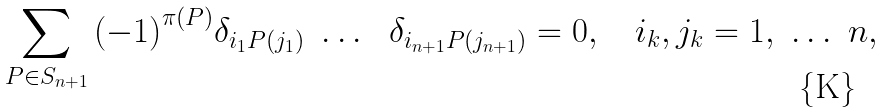Convert formula to latex. <formula><loc_0><loc_0><loc_500><loc_500>\sum _ { P \in { S } _ { n + 1 } } { { ( - 1 ) } ^ { \pi ( P ) } { \delta } _ { { { i } _ { 1 } } { P ( j _ { 1 } ) } } \ \dots \ \ { \delta } _ { { { i } _ { n + 1 } } { P ( j _ { n + 1 } ) } } } = 0 , \quad { i } _ { k } , { j } _ { k } = 1 , \ \dots \ n ,</formula> 